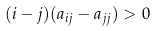Convert formula to latex. <formula><loc_0><loc_0><loc_500><loc_500>( i - j ) ( a _ { i j } - a _ { j j } ) > 0</formula> 